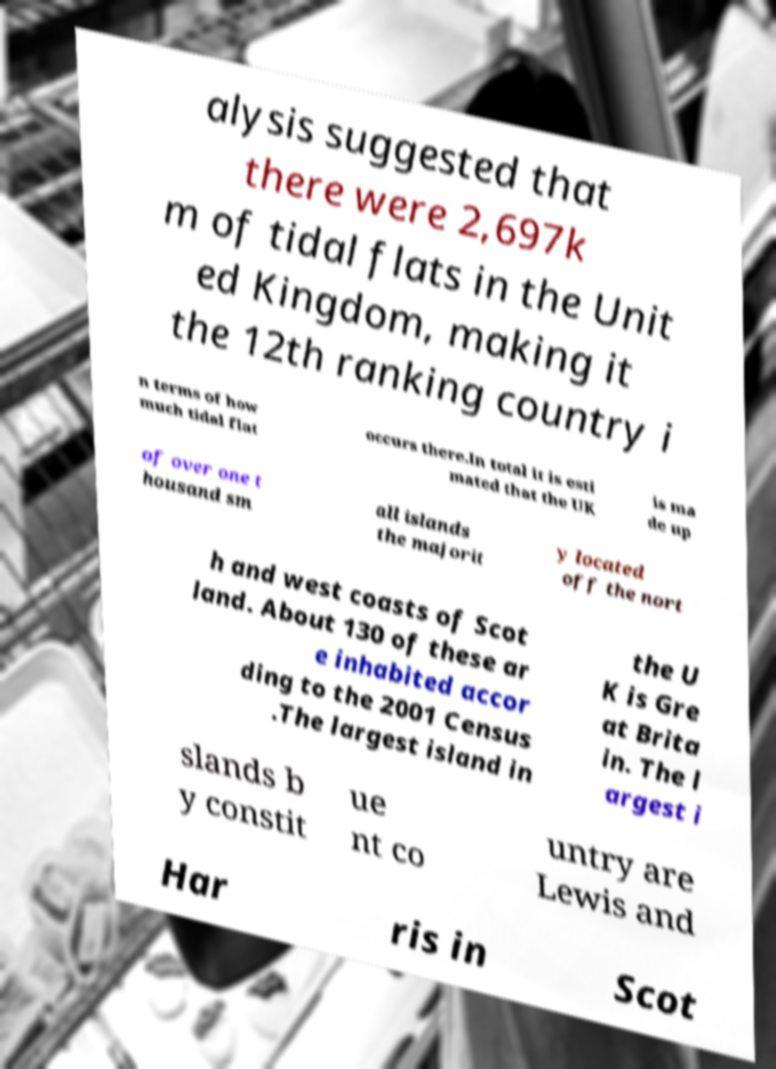Could you extract and type out the text from this image? alysis suggested that there were 2,697k m of tidal flats in the Unit ed Kingdom, making it the 12th ranking country i n terms of how much tidal flat occurs there.In total it is esti mated that the UK is ma de up of over one t housand sm all islands the majorit y located off the nort h and west coasts of Scot land. About 130 of these ar e inhabited accor ding to the 2001 Census .The largest island in the U K is Gre at Brita in. The l argest i slands b y constit ue nt co untry are Lewis and Har ris in Scot 